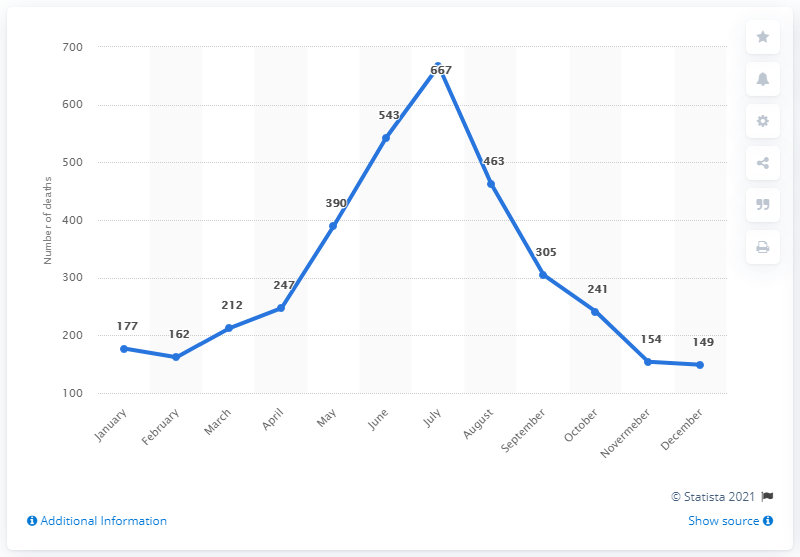Specify some key components in this picture. In July of 2018, there were 667 drowning deaths. In 2018, July was the deadliest month for drowning deaths in the United States. 